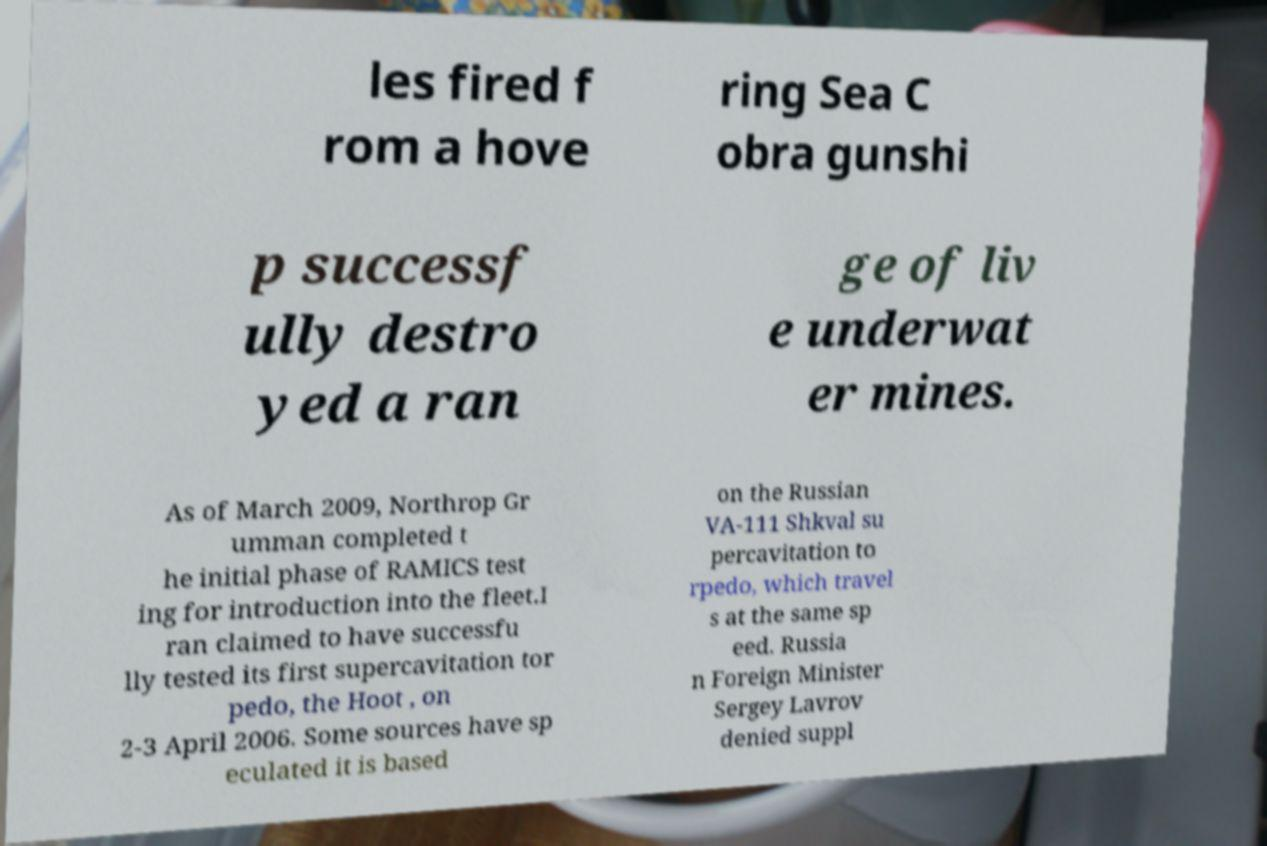Please identify and transcribe the text found in this image. les fired f rom a hove ring Sea C obra gunshi p successf ully destro yed a ran ge of liv e underwat er mines. As of March 2009, Northrop Gr umman completed t he initial phase of RAMICS test ing for introduction into the fleet.I ran claimed to have successfu lly tested its first supercavitation tor pedo, the Hoot , on 2-3 April 2006. Some sources have sp eculated it is based on the Russian VA-111 Shkval su percavitation to rpedo, which travel s at the same sp eed. Russia n Foreign Minister Sergey Lavrov denied suppl 